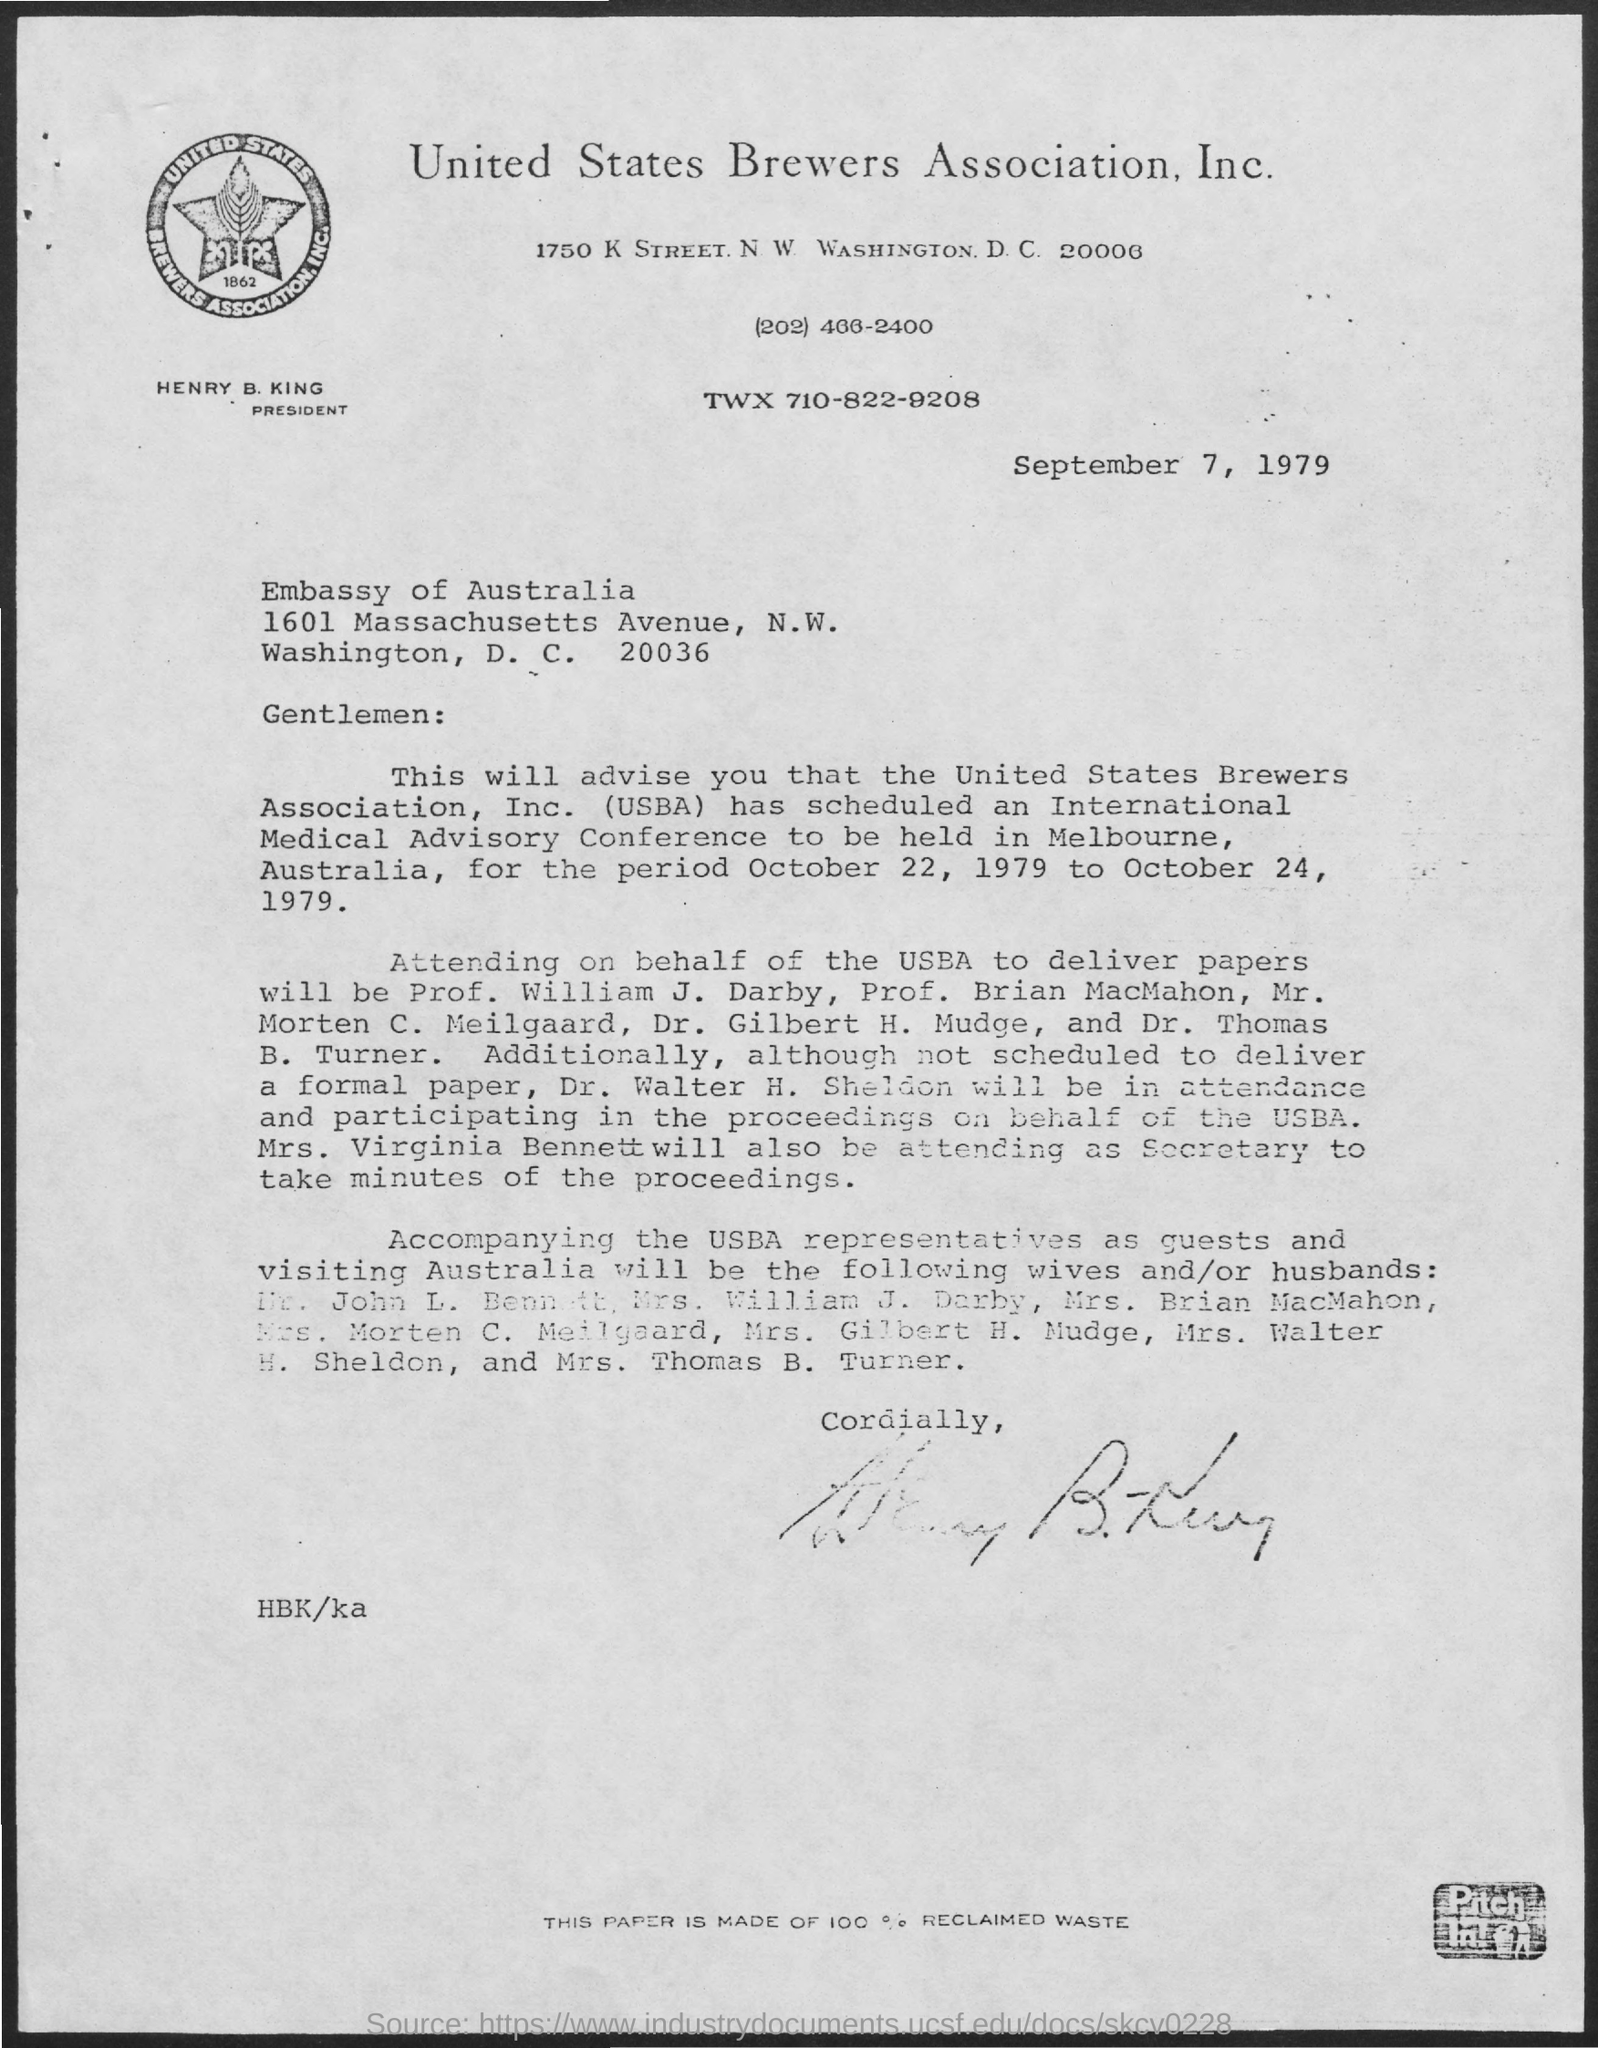Identify some key points in this picture. The name of the association is the United States Brewers Association, Inc. The date mentioned at the beginning of this document is September 7, 1979. The President of the Association is named Henry B. King. 